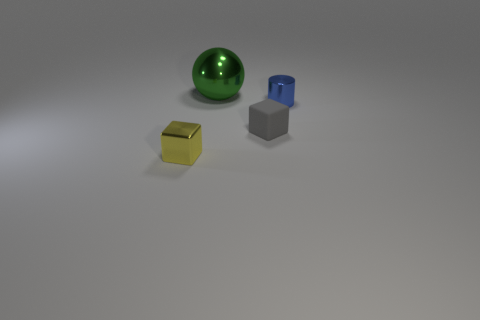Add 3 yellow shiny balls. How many objects exist? 7 Subtract all balls. How many objects are left? 3 Subtract all large blue metallic blocks. Subtract all green spheres. How many objects are left? 3 Add 3 small yellow shiny things. How many small yellow shiny things are left? 4 Add 3 small yellow shiny cubes. How many small yellow shiny cubes exist? 4 Subtract 0 yellow cylinders. How many objects are left? 4 